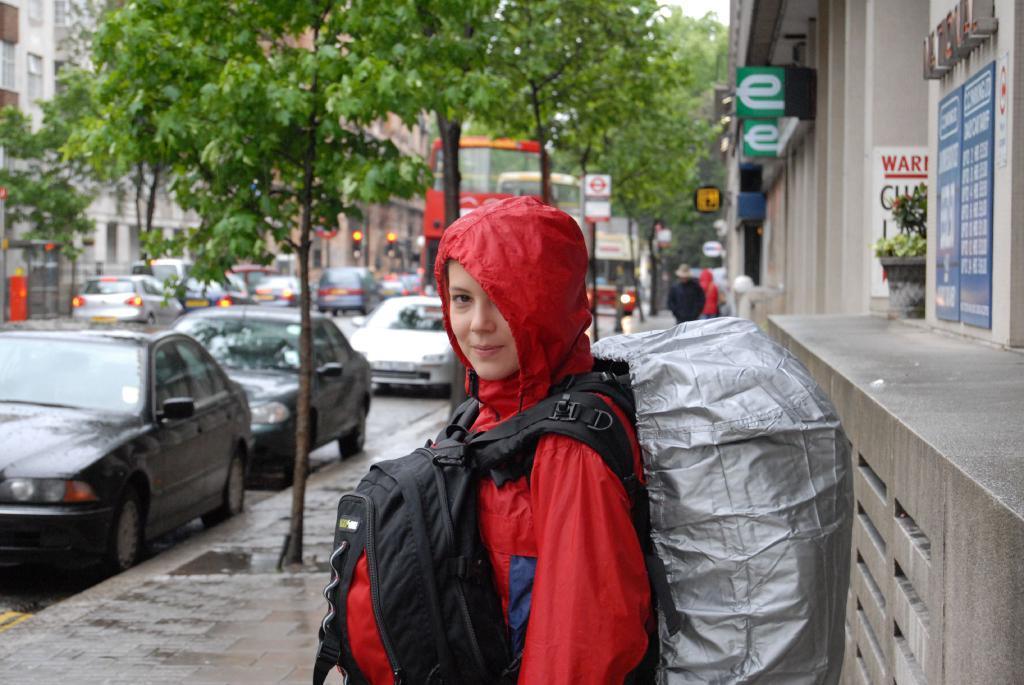Can you describe this image briefly? In this image we can see a boy is standing, he is wearing a bag, at the back there is a building, there are birds, there are cars travelling on a road, there are trees, there is a traffic signal, there are sign boards, there is sky at the top. 